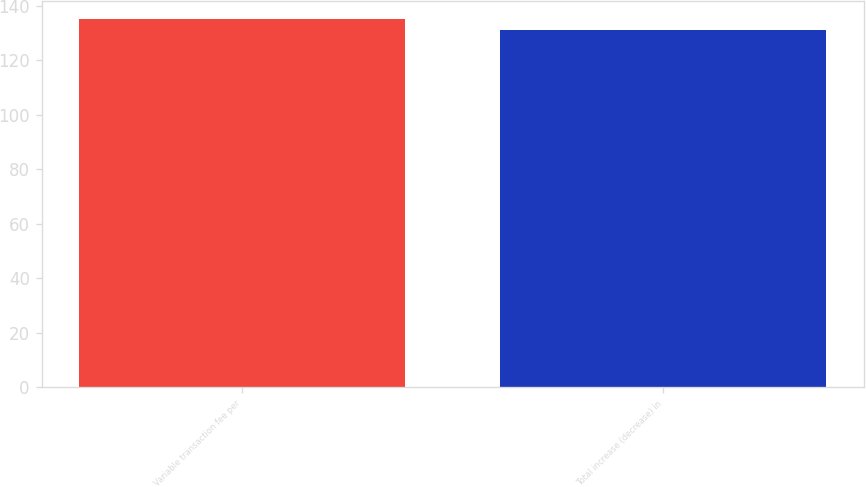Convert chart. <chart><loc_0><loc_0><loc_500><loc_500><bar_chart><fcel>Variable transaction fee per<fcel>Total increase (decrease) in<nl><fcel>135<fcel>131<nl></chart> 